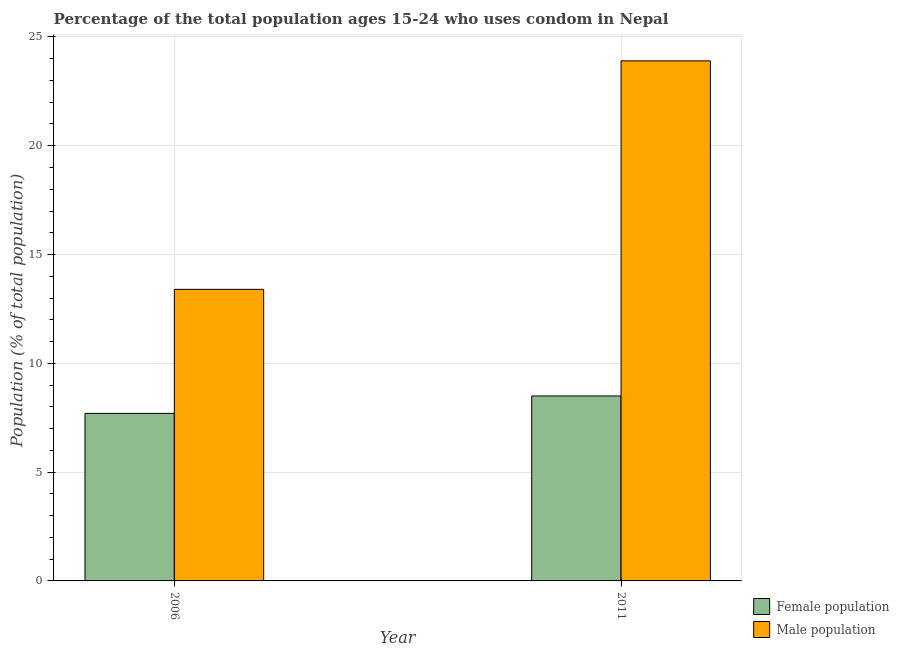How many different coloured bars are there?
Ensure brevity in your answer.  2. How many groups of bars are there?
Make the answer very short. 2. How many bars are there on the 1st tick from the right?
Your answer should be very brief. 2. What is the label of the 2nd group of bars from the left?
Make the answer very short. 2011. In how many cases, is the number of bars for a given year not equal to the number of legend labels?
Offer a very short reply. 0. What is the female population in 2006?
Your answer should be compact. 7.7. Across all years, what is the maximum male population?
Your answer should be very brief. 23.9. Across all years, what is the minimum male population?
Make the answer very short. 13.4. In which year was the male population minimum?
Offer a terse response. 2006. What is the difference between the male population in 2006 and that in 2011?
Offer a very short reply. -10.5. What is the difference between the female population in 2011 and the male population in 2006?
Your answer should be compact. 0.8. In how many years, is the male population greater than 17 %?
Your answer should be very brief. 1. What is the ratio of the male population in 2006 to that in 2011?
Make the answer very short. 0.56. What does the 2nd bar from the left in 2006 represents?
Provide a short and direct response. Male population. What does the 1st bar from the right in 2006 represents?
Give a very brief answer. Male population. How many years are there in the graph?
Your answer should be very brief. 2. What is the difference between two consecutive major ticks on the Y-axis?
Offer a terse response. 5. Where does the legend appear in the graph?
Provide a succinct answer. Bottom right. How many legend labels are there?
Your answer should be very brief. 2. What is the title of the graph?
Provide a succinct answer. Percentage of the total population ages 15-24 who uses condom in Nepal. Does "Number of departures" appear as one of the legend labels in the graph?
Provide a succinct answer. No. What is the label or title of the X-axis?
Provide a succinct answer. Year. What is the label or title of the Y-axis?
Offer a very short reply. Population (% of total population) . What is the Population (% of total population)  in Female population in 2011?
Keep it short and to the point. 8.5. What is the Population (% of total population)  of Male population in 2011?
Your answer should be very brief. 23.9. Across all years, what is the maximum Population (% of total population)  of Female population?
Your answer should be very brief. 8.5. Across all years, what is the maximum Population (% of total population)  of Male population?
Give a very brief answer. 23.9. Across all years, what is the minimum Population (% of total population)  of Female population?
Give a very brief answer. 7.7. Across all years, what is the minimum Population (% of total population)  in Male population?
Your response must be concise. 13.4. What is the total Population (% of total population)  in Female population in the graph?
Provide a short and direct response. 16.2. What is the total Population (% of total population)  of Male population in the graph?
Your answer should be compact. 37.3. What is the difference between the Population (% of total population)  of Female population in 2006 and that in 2011?
Your response must be concise. -0.8. What is the difference between the Population (% of total population)  of Male population in 2006 and that in 2011?
Offer a very short reply. -10.5. What is the difference between the Population (% of total population)  of Female population in 2006 and the Population (% of total population)  of Male population in 2011?
Keep it short and to the point. -16.2. What is the average Population (% of total population)  in Female population per year?
Your response must be concise. 8.1. What is the average Population (% of total population)  in Male population per year?
Your answer should be compact. 18.65. In the year 2011, what is the difference between the Population (% of total population)  of Female population and Population (% of total population)  of Male population?
Your response must be concise. -15.4. What is the ratio of the Population (% of total population)  of Female population in 2006 to that in 2011?
Your response must be concise. 0.91. What is the ratio of the Population (% of total population)  in Male population in 2006 to that in 2011?
Offer a terse response. 0.56. What is the difference between the highest and the second highest Population (% of total population)  in Male population?
Your answer should be very brief. 10.5. What is the difference between the highest and the lowest Population (% of total population)  of Female population?
Provide a succinct answer. 0.8. 